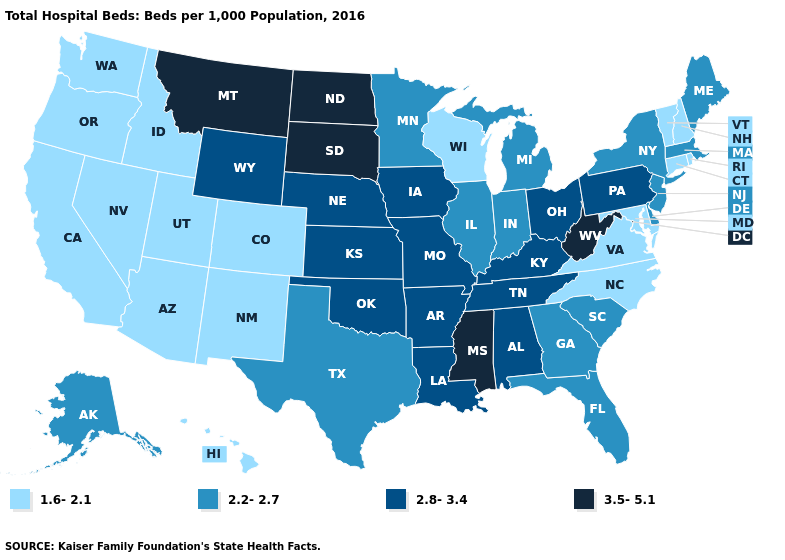What is the value of Indiana?
Short answer required. 2.2-2.7. Name the states that have a value in the range 2.2-2.7?
Give a very brief answer. Alaska, Delaware, Florida, Georgia, Illinois, Indiana, Maine, Massachusetts, Michigan, Minnesota, New Jersey, New York, South Carolina, Texas. Name the states that have a value in the range 1.6-2.1?
Short answer required. Arizona, California, Colorado, Connecticut, Hawaii, Idaho, Maryland, Nevada, New Hampshire, New Mexico, North Carolina, Oregon, Rhode Island, Utah, Vermont, Virginia, Washington, Wisconsin. What is the value of California?
Concise answer only. 1.6-2.1. What is the value of Delaware?
Be succinct. 2.2-2.7. What is the value of Texas?
Quick response, please. 2.2-2.7. Name the states that have a value in the range 3.5-5.1?
Write a very short answer. Mississippi, Montana, North Dakota, South Dakota, West Virginia. What is the value of Maine?
Give a very brief answer. 2.2-2.7. Does Rhode Island have the lowest value in the Northeast?
Keep it brief. Yes. Among the states that border Oregon , which have the highest value?
Answer briefly. California, Idaho, Nevada, Washington. Does Minnesota have a higher value than South Carolina?
Write a very short answer. No. Which states have the lowest value in the USA?
Be succinct. Arizona, California, Colorado, Connecticut, Hawaii, Idaho, Maryland, Nevada, New Hampshire, New Mexico, North Carolina, Oregon, Rhode Island, Utah, Vermont, Virginia, Washington, Wisconsin. How many symbols are there in the legend?
Be succinct. 4. What is the value of Iowa?
Be succinct. 2.8-3.4. Name the states that have a value in the range 2.8-3.4?
Answer briefly. Alabama, Arkansas, Iowa, Kansas, Kentucky, Louisiana, Missouri, Nebraska, Ohio, Oklahoma, Pennsylvania, Tennessee, Wyoming. 